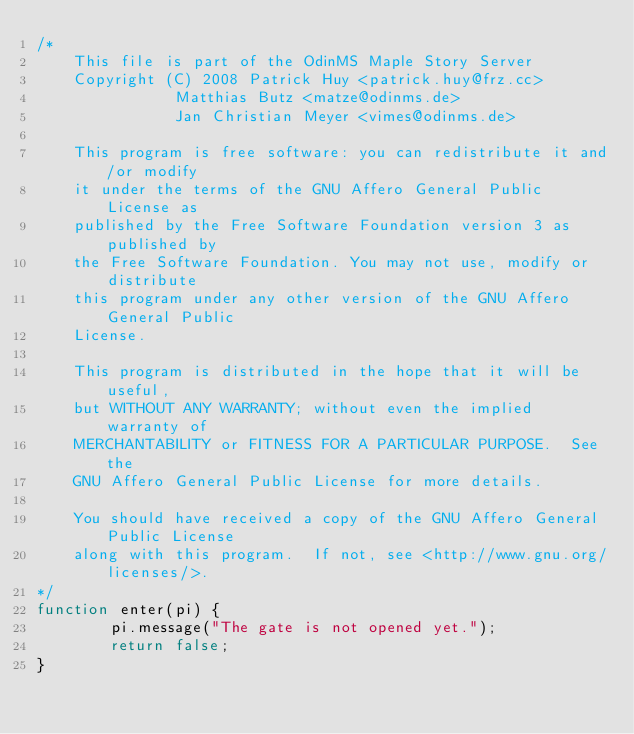<code> <loc_0><loc_0><loc_500><loc_500><_JavaScript_>/*
	This file is part of the OdinMS Maple Story Server
    Copyright (C) 2008 Patrick Huy <patrick.huy@frz.cc>
		       Matthias Butz <matze@odinms.de>
		       Jan Christian Meyer <vimes@odinms.de>

    This program is free software: you can redistribute it and/or modify
    it under the terms of the GNU Affero General Public License as
    published by the Free Software Foundation version 3 as published by
    the Free Software Foundation. You may not use, modify or distribute
    this program under any other version of the GNU Affero General Public
    License.

    This program is distributed in the hope that it will be useful,
    but WITHOUT ANY WARRANTY; without even the implied warranty of
    MERCHANTABILITY or FITNESS FOR A PARTICULAR PURPOSE.  See the
    GNU Affero General Public License for more details.

    You should have received a copy of the GNU Affero General Public License
    along with this program.  If not, see <http://www.gnu.org/licenses/>.
*/
function enter(pi) {
        pi.message("The gate is not opened yet.");
        return false;
}</code> 